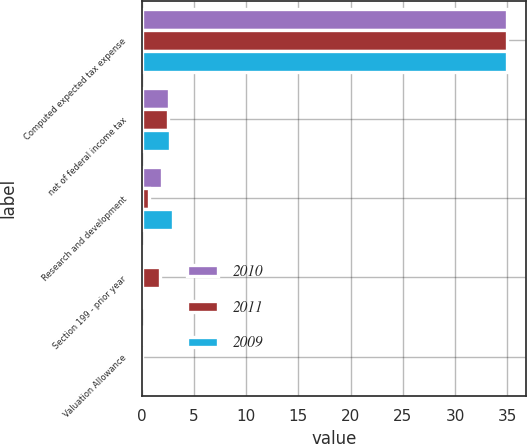<chart> <loc_0><loc_0><loc_500><loc_500><stacked_bar_chart><ecel><fcel>Computed expected tax expense<fcel>net of federal income tax<fcel>Research and development<fcel>Section 199 - prior year<fcel>Valuation Allowance<nl><fcel>2010<fcel>35<fcel>2.6<fcel>2<fcel>0.2<fcel>0<nl><fcel>2011<fcel>35<fcel>2.5<fcel>0.7<fcel>1.8<fcel>0<nl><fcel>2009<fcel>35<fcel>2.7<fcel>3<fcel>0<fcel>0.2<nl></chart> 